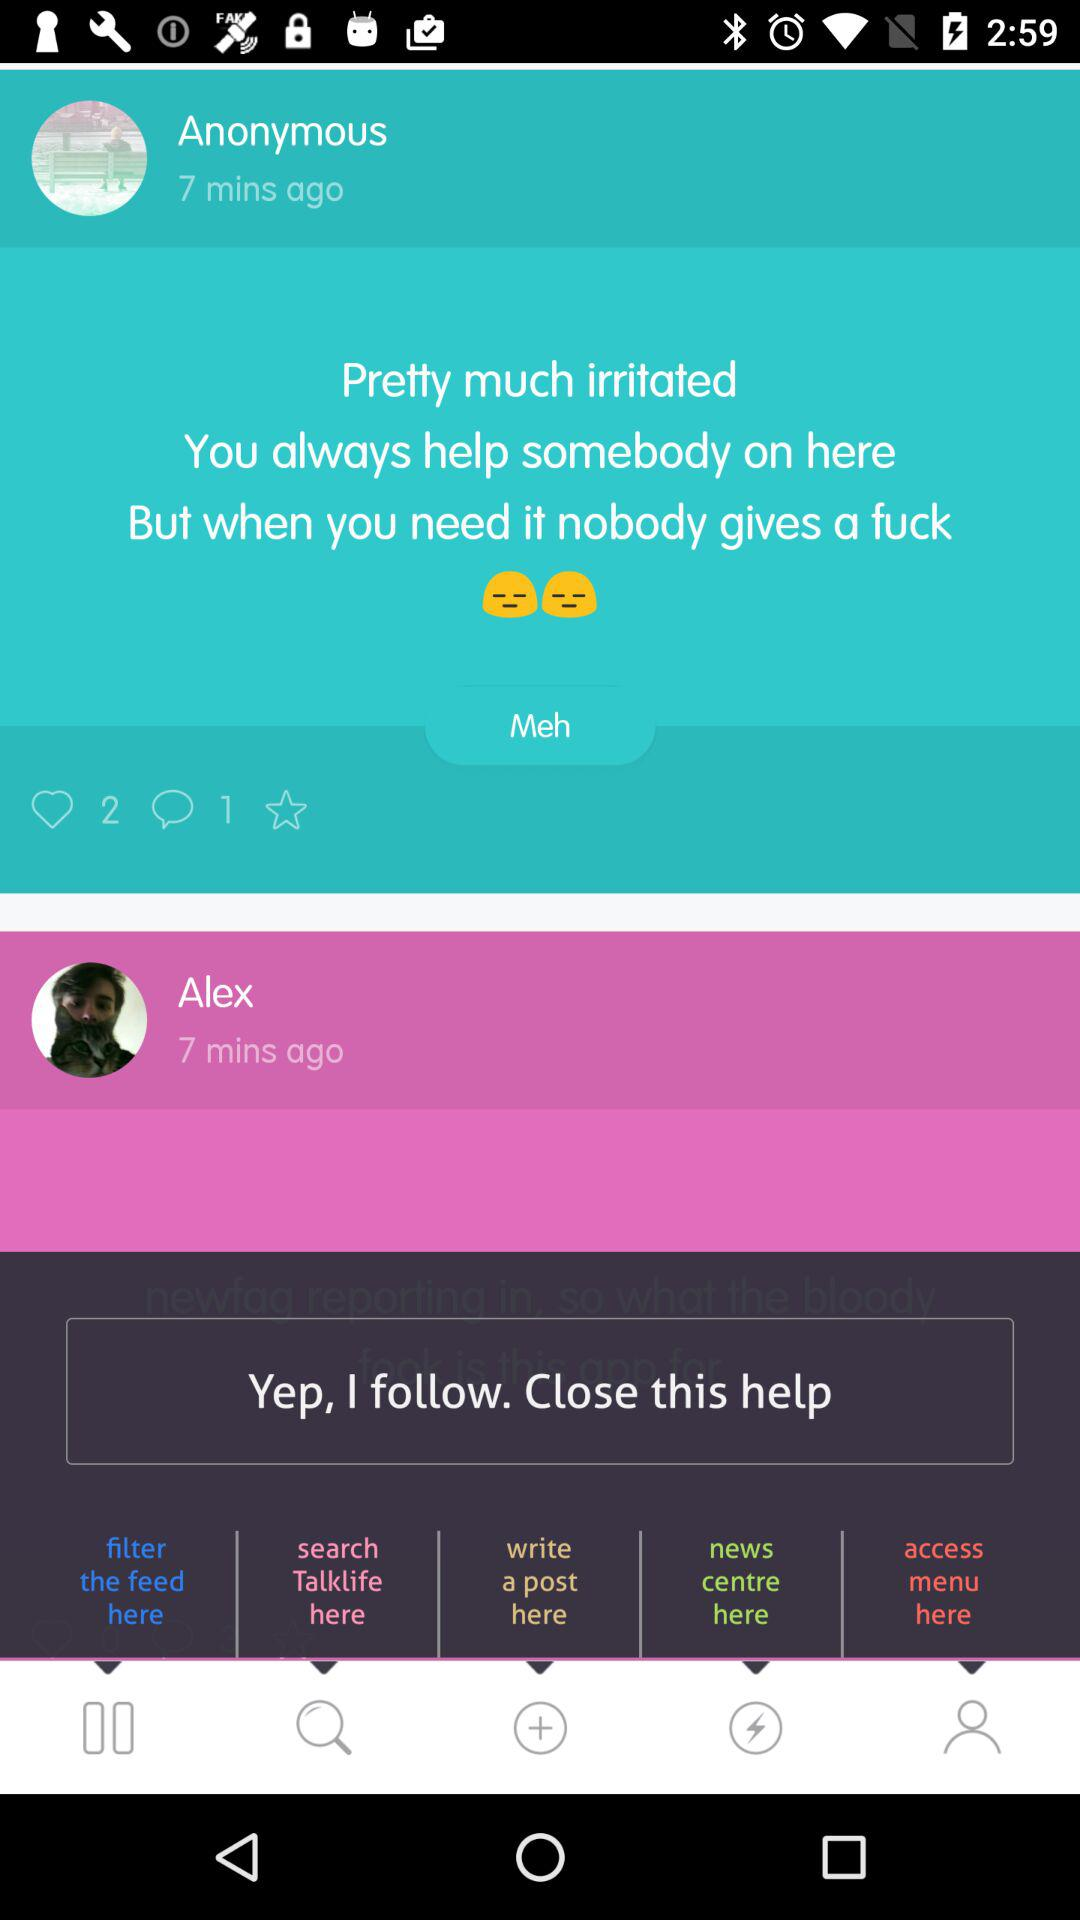How many comments are there? There is 1 comment. 